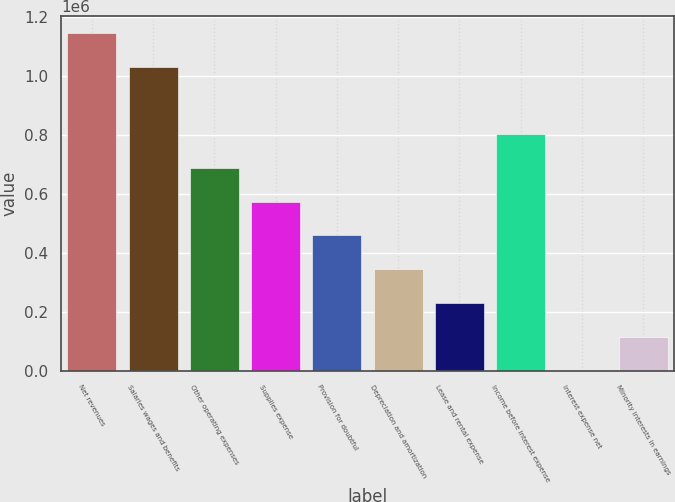Convert chart to OTSL. <chart><loc_0><loc_0><loc_500><loc_500><bar_chart><fcel>Net revenues<fcel>Salaries wages and benefits<fcel>Other operating expenses<fcel>Supplies expense<fcel>Provision for doubtful<fcel>Depreciation and amortization<fcel>Lease and rental expense<fcel>Income before interest expense<fcel>Interest expense net<fcel>Minority interests in earnings<nl><fcel>1.14608e+06<fcel>1.03151e+06<fcel>687811<fcel>573244<fcel>458678<fcel>344111<fcel>229544<fcel>802378<fcel>411<fcel>114978<nl></chart> 